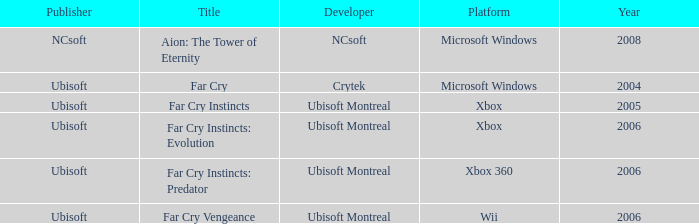What is the average year that has far cry vengeance as the title? 2006.0. Parse the full table. {'header': ['Publisher', 'Title', 'Developer', 'Platform', 'Year'], 'rows': [['NCsoft', 'Aion: The Tower of Eternity', 'NCsoft', 'Microsoft Windows', '2008'], ['Ubisoft', 'Far Cry', 'Crytek', 'Microsoft Windows', '2004'], ['Ubisoft', 'Far Cry Instincts', 'Ubisoft Montreal', 'Xbox', '2005'], ['Ubisoft', 'Far Cry Instincts: Evolution', 'Ubisoft Montreal', 'Xbox', '2006'], ['Ubisoft', 'Far Cry Instincts: Predator', 'Ubisoft Montreal', 'Xbox 360', '2006'], ['Ubisoft', 'Far Cry Vengeance', 'Ubisoft Montreal', 'Wii', '2006']]} 